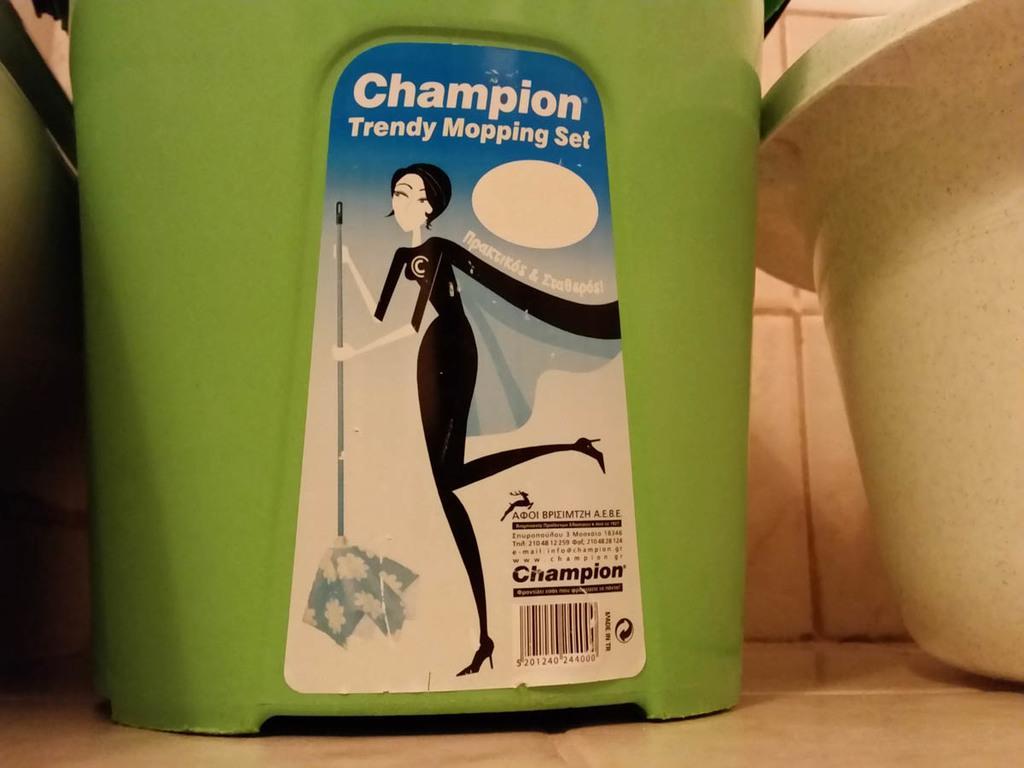Can you describe this image briefly? There is a green mop tub which has a sticker on it. There is a plastic tub on the right and there are tiles at the back. 